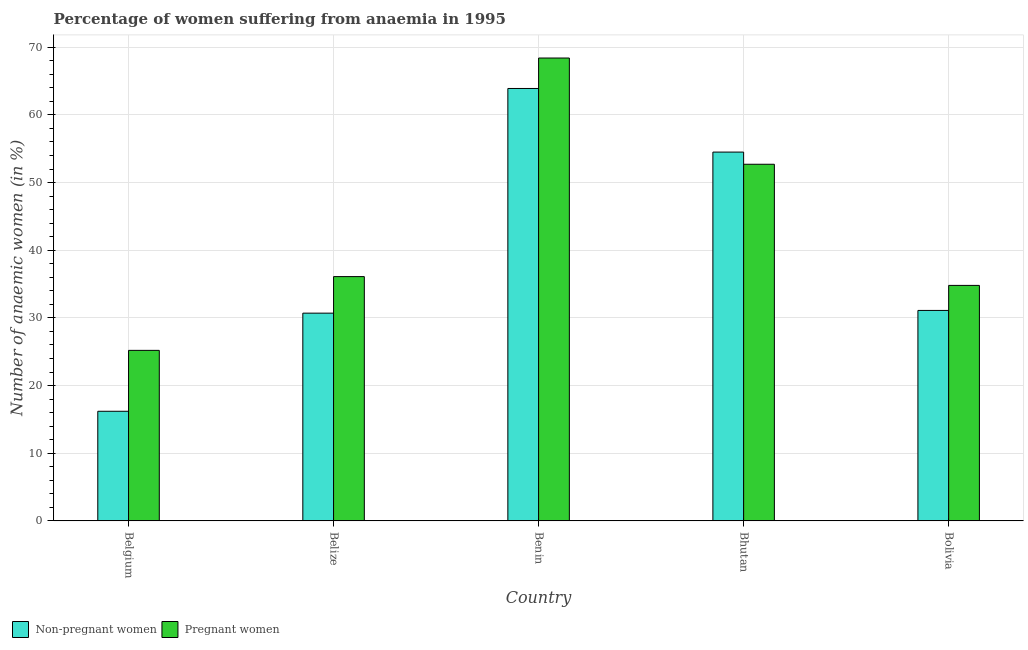How many groups of bars are there?
Your answer should be compact. 5. Are the number of bars on each tick of the X-axis equal?
Make the answer very short. Yes. How many bars are there on the 1st tick from the left?
Give a very brief answer. 2. How many bars are there on the 3rd tick from the right?
Offer a very short reply. 2. What is the label of the 1st group of bars from the left?
Your response must be concise. Belgium. In how many cases, is the number of bars for a given country not equal to the number of legend labels?
Give a very brief answer. 0. What is the percentage of pregnant anaemic women in Bhutan?
Give a very brief answer. 52.7. Across all countries, what is the maximum percentage of non-pregnant anaemic women?
Keep it short and to the point. 63.9. Across all countries, what is the minimum percentage of pregnant anaemic women?
Provide a succinct answer. 25.2. In which country was the percentage of non-pregnant anaemic women maximum?
Your answer should be compact. Benin. In which country was the percentage of pregnant anaemic women minimum?
Your response must be concise. Belgium. What is the total percentage of non-pregnant anaemic women in the graph?
Give a very brief answer. 196.4. What is the difference between the percentage of pregnant anaemic women in Benin and that in Bhutan?
Offer a terse response. 15.7. What is the difference between the percentage of non-pregnant anaemic women in Benin and the percentage of pregnant anaemic women in Bhutan?
Offer a very short reply. 11.2. What is the average percentage of non-pregnant anaemic women per country?
Your answer should be very brief. 39.28. What is the difference between the percentage of pregnant anaemic women and percentage of non-pregnant anaemic women in Belize?
Ensure brevity in your answer.  5.4. In how many countries, is the percentage of pregnant anaemic women greater than 44 %?
Offer a very short reply. 2. What is the ratio of the percentage of pregnant anaemic women in Benin to that in Bolivia?
Your answer should be very brief. 1.97. Is the difference between the percentage of pregnant anaemic women in Benin and Bolivia greater than the difference between the percentage of non-pregnant anaemic women in Benin and Bolivia?
Ensure brevity in your answer.  Yes. What is the difference between the highest and the second highest percentage of non-pregnant anaemic women?
Provide a succinct answer. 9.4. What is the difference between the highest and the lowest percentage of non-pregnant anaemic women?
Your answer should be very brief. 47.7. In how many countries, is the percentage of non-pregnant anaemic women greater than the average percentage of non-pregnant anaemic women taken over all countries?
Give a very brief answer. 2. What does the 2nd bar from the left in Bhutan represents?
Give a very brief answer. Pregnant women. What does the 2nd bar from the right in Belize represents?
Provide a short and direct response. Non-pregnant women. How many bars are there?
Offer a terse response. 10. Are all the bars in the graph horizontal?
Give a very brief answer. No. What is the difference between two consecutive major ticks on the Y-axis?
Your answer should be very brief. 10. Are the values on the major ticks of Y-axis written in scientific E-notation?
Provide a short and direct response. No. Where does the legend appear in the graph?
Offer a terse response. Bottom left. How are the legend labels stacked?
Keep it short and to the point. Horizontal. What is the title of the graph?
Ensure brevity in your answer.  Percentage of women suffering from anaemia in 1995. Does "Technicians" appear as one of the legend labels in the graph?
Your answer should be very brief. No. What is the label or title of the Y-axis?
Make the answer very short. Number of anaemic women (in %). What is the Number of anaemic women (in %) of Pregnant women in Belgium?
Offer a very short reply. 25.2. What is the Number of anaemic women (in %) of Non-pregnant women in Belize?
Provide a succinct answer. 30.7. What is the Number of anaemic women (in %) of Pregnant women in Belize?
Offer a terse response. 36.1. What is the Number of anaemic women (in %) in Non-pregnant women in Benin?
Provide a succinct answer. 63.9. What is the Number of anaemic women (in %) of Pregnant women in Benin?
Make the answer very short. 68.4. What is the Number of anaemic women (in %) in Non-pregnant women in Bhutan?
Keep it short and to the point. 54.5. What is the Number of anaemic women (in %) in Pregnant women in Bhutan?
Ensure brevity in your answer.  52.7. What is the Number of anaemic women (in %) of Non-pregnant women in Bolivia?
Make the answer very short. 31.1. What is the Number of anaemic women (in %) of Pregnant women in Bolivia?
Offer a terse response. 34.8. Across all countries, what is the maximum Number of anaemic women (in %) of Non-pregnant women?
Make the answer very short. 63.9. Across all countries, what is the maximum Number of anaemic women (in %) in Pregnant women?
Give a very brief answer. 68.4. Across all countries, what is the minimum Number of anaemic women (in %) in Pregnant women?
Your response must be concise. 25.2. What is the total Number of anaemic women (in %) in Non-pregnant women in the graph?
Keep it short and to the point. 196.4. What is the total Number of anaemic women (in %) of Pregnant women in the graph?
Offer a terse response. 217.2. What is the difference between the Number of anaemic women (in %) of Pregnant women in Belgium and that in Belize?
Offer a very short reply. -10.9. What is the difference between the Number of anaemic women (in %) in Non-pregnant women in Belgium and that in Benin?
Your answer should be compact. -47.7. What is the difference between the Number of anaemic women (in %) of Pregnant women in Belgium and that in Benin?
Offer a very short reply. -43.2. What is the difference between the Number of anaemic women (in %) in Non-pregnant women in Belgium and that in Bhutan?
Provide a short and direct response. -38.3. What is the difference between the Number of anaemic women (in %) of Pregnant women in Belgium and that in Bhutan?
Your answer should be very brief. -27.5. What is the difference between the Number of anaemic women (in %) of Non-pregnant women in Belgium and that in Bolivia?
Give a very brief answer. -14.9. What is the difference between the Number of anaemic women (in %) in Non-pregnant women in Belize and that in Benin?
Your response must be concise. -33.2. What is the difference between the Number of anaemic women (in %) of Pregnant women in Belize and that in Benin?
Provide a short and direct response. -32.3. What is the difference between the Number of anaemic women (in %) of Non-pregnant women in Belize and that in Bhutan?
Keep it short and to the point. -23.8. What is the difference between the Number of anaemic women (in %) of Pregnant women in Belize and that in Bhutan?
Give a very brief answer. -16.6. What is the difference between the Number of anaemic women (in %) in Non-pregnant women in Benin and that in Bolivia?
Give a very brief answer. 32.8. What is the difference between the Number of anaemic women (in %) of Pregnant women in Benin and that in Bolivia?
Provide a succinct answer. 33.6. What is the difference between the Number of anaemic women (in %) in Non-pregnant women in Bhutan and that in Bolivia?
Give a very brief answer. 23.4. What is the difference between the Number of anaemic women (in %) in Pregnant women in Bhutan and that in Bolivia?
Provide a succinct answer. 17.9. What is the difference between the Number of anaemic women (in %) of Non-pregnant women in Belgium and the Number of anaemic women (in %) of Pregnant women in Belize?
Offer a very short reply. -19.9. What is the difference between the Number of anaemic women (in %) of Non-pregnant women in Belgium and the Number of anaemic women (in %) of Pregnant women in Benin?
Your answer should be compact. -52.2. What is the difference between the Number of anaemic women (in %) in Non-pregnant women in Belgium and the Number of anaemic women (in %) in Pregnant women in Bhutan?
Your answer should be compact. -36.5. What is the difference between the Number of anaemic women (in %) of Non-pregnant women in Belgium and the Number of anaemic women (in %) of Pregnant women in Bolivia?
Your response must be concise. -18.6. What is the difference between the Number of anaemic women (in %) of Non-pregnant women in Belize and the Number of anaemic women (in %) of Pregnant women in Benin?
Your response must be concise. -37.7. What is the difference between the Number of anaemic women (in %) in Non-pregnant women in Belize and the Number of anaemic women (in %) in Pregnant women in Bhutan?
Provide a short and direct response. -22. What is the difference between the Number of anaemic women (in %) in Non-pregnant women in Belize and the Number of anaemic women (in %) in Pregnant women in Bolivia?
Keep it short and to the point. -4.1. What is the difference between the Number of anaemic women (in %) in Non-pregnant women in Benin and the Number of anaemic women (in %) in Pregnant women in Bhutan?
Ensure brevity in your answer.  11.2. What is the difference between the Number of anaemic women (in %) of Non-pregnant women in Benin and the Number of anaemic women (in %) of Pregnant women in Bolivia?
Offer a terse response. 29.1. What is the average Number of anaemic women (in %) in Non-pregnant women per country?
Ensure brevity in your answer.  39.28. What is the average Number of anaemic women (in %) of Pregnant women per country?
Your response must be concise. 43.44. What is the difference between the Number of anaemic women (in %) in Non-pregnant women and Number of anaemic women (in %) in Pregnant women in Belgium?
Give a very brief answer. -9. What is the difference between the Number of anaemic women (in %) in Non-pregnant women and Number of anaemic women (in %) in Pregnant women in Bolivia?
Ensure brevity in your answer.  -3.7. What is the ratio of the Number of anaemic women (in %) in Non-pregnant women in Belgium to that in Belize?
Your answer should be very brief. 0.53. What is the ratio of the Number of anaemic women (in %) of Pregnant women in Belgium to that in Belize?
Your response must be concise. 0.7. What is the ratio of the Number of anaemic women (in %) in Non-pregnant women in Belgium to that in Benin?
Your response must be concise. 0.25. What is the ratio of the Number of anaemic women (in %) in Pregnant women in Belgium to that in Benin?
Your answer should be compact. 0.37. What is the ratio of the Number of anaemic women (in %) of Non-pregnant women in Belgium to that in Bhutan?
Give a very brief answer. 0.3. What is the ratio of the Number of anaemic women (in %) of Pregnant women in Belgium to that in Bhutan?
Your answer should be compact. 0.48. What is the ratio of the Number of anaemic women (in %) of Non-pregnant women in Belgium to that in Bolivia?
Your response must be concise. 0.52. What is the ratio of the Number of anaemic women (in %) of Pregnant women in Belgium to that in Bolivia?
Your response must be concise. 0.72. What is the ratio of the Number of anaemic women (in %) in Non-pregnant women in Belize to that in Benin?
Give a very brief answer. 0.48. What is the ratio of the Number of anaemic women (in %) of Pregnant women in Belize to that in Benin?
Provide a short and direct response. 0.53. What is the ratio of the Number of anaemic women (in %) of Non-pregnant women in Belize to that in Bhutan?
Your answer should be very brief. 0.56. What is the ratio of the Number of anaemic women (in %) in Pregnant women in Belize to that in Bhutan?
Provide a succinct answer. 0.69. What is the ratio of the Number of anaemic women (in %) of Non-pregnant women in Belize to that in Bolivia?
Ensure brevity in your answer.  0.99. What is the ratio of the Number of anaemic women (in %) of Pregnant women in Belize to that in Bolivia?
Give a very brief answer. 1.04. What is the ratio of the Number of anaemic women (in %) in Non-pregnant women in Benin to that in Bhutan?
Give a very brief answer. 1.17. What is the ratio of the Number of anaemic women (in %) of Pregnant women in Benin to that in Bhutan?
Provide a short and direct response. 1.3. What is the ratio of the Number of anaemic women (in %) in Non-pregnant women in Benin to that in Bolivia?
Ensure brevity in your answer.  2.05. What is the ratio of the Number of anaemic women (in %) in Pregnant women in Benin to that in Bolivia?
Offer a terse response. 1.97. What is the ratio of the Number of anaemic women (in %) of Non-pregnant women in Bhutan to that in Bolivia?
Your answer should be compact. 1.75. What is the ratio of the Number of anaemic women (in %) in Pregnant women in Bhutan to that in Bolivia?
Make the answer very short. 1.51. What is the difference between the highest and the second highest Number of anaemic women (in %) of Non-pregnant women?
Provide a succinct answer. 9.4. What is the difference between the highest and the second highest Number of anaemic women (in %) of Pregnant women?
Offer a terse response. 15.7. What is the difference between the highest and the lowest Number of anaemic women (in %) in Non-pregnant women?
Your answer should be very brief. 47.7. What is the difference between the highest and the lowest Number of anaemic women (in %) in Pregnant women?
Your response must be concise. 43.2. 